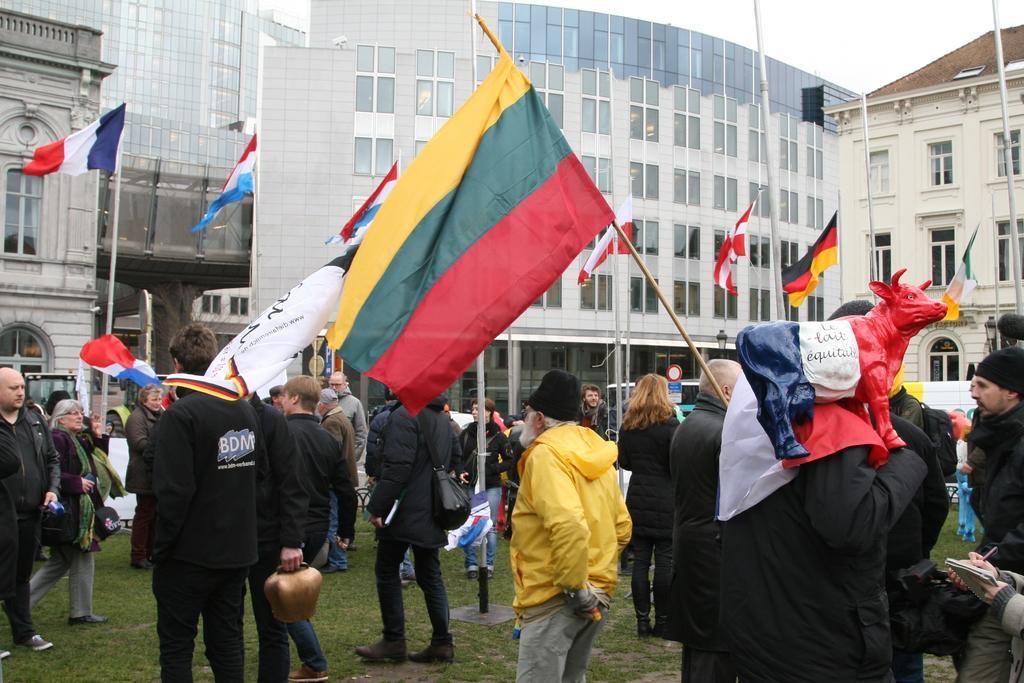Please provide a concise description of this image. In the image there are many people standing on the ground and they are holding some flags in their hands and behind them there are many buildings. 